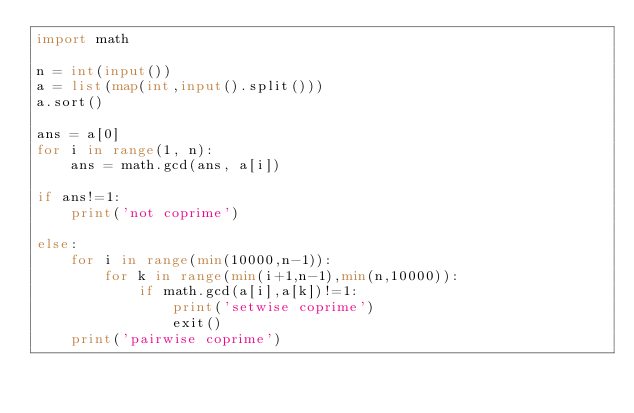<code> <loc_0><loc_0><loc_500><loc_500><_Python_>import math

n = int(input())
a = list(map(int,input().split()))
a.sort()

ans = a[0]
for i in range(1, n):
    ans = math.gcd(ans, a[i])

if ans!=1:
    print('not coprime')

else:
    for i in range(min(10000,n-1)):
        for k in range(min(i+1,n-1),min(n,10000)):
            if math.gcd(a[i],a[k])!=1:
                print('setwise coprime')
                exit()
    print('pairwise coprime')
</code> 